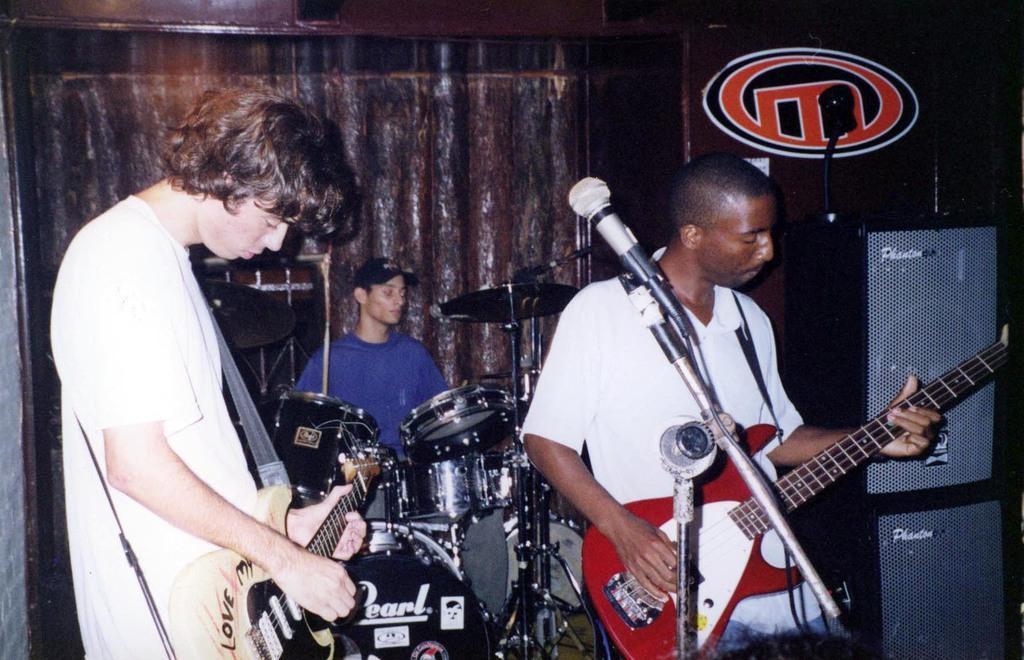Describe this image in one or two sentences. A rock band is performing on stage. 